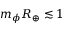<formula> <loc_0><loc_0><loc_500><loc_500>m _ { \phi } R _ { \oplus } \lesssim 1</formula> 